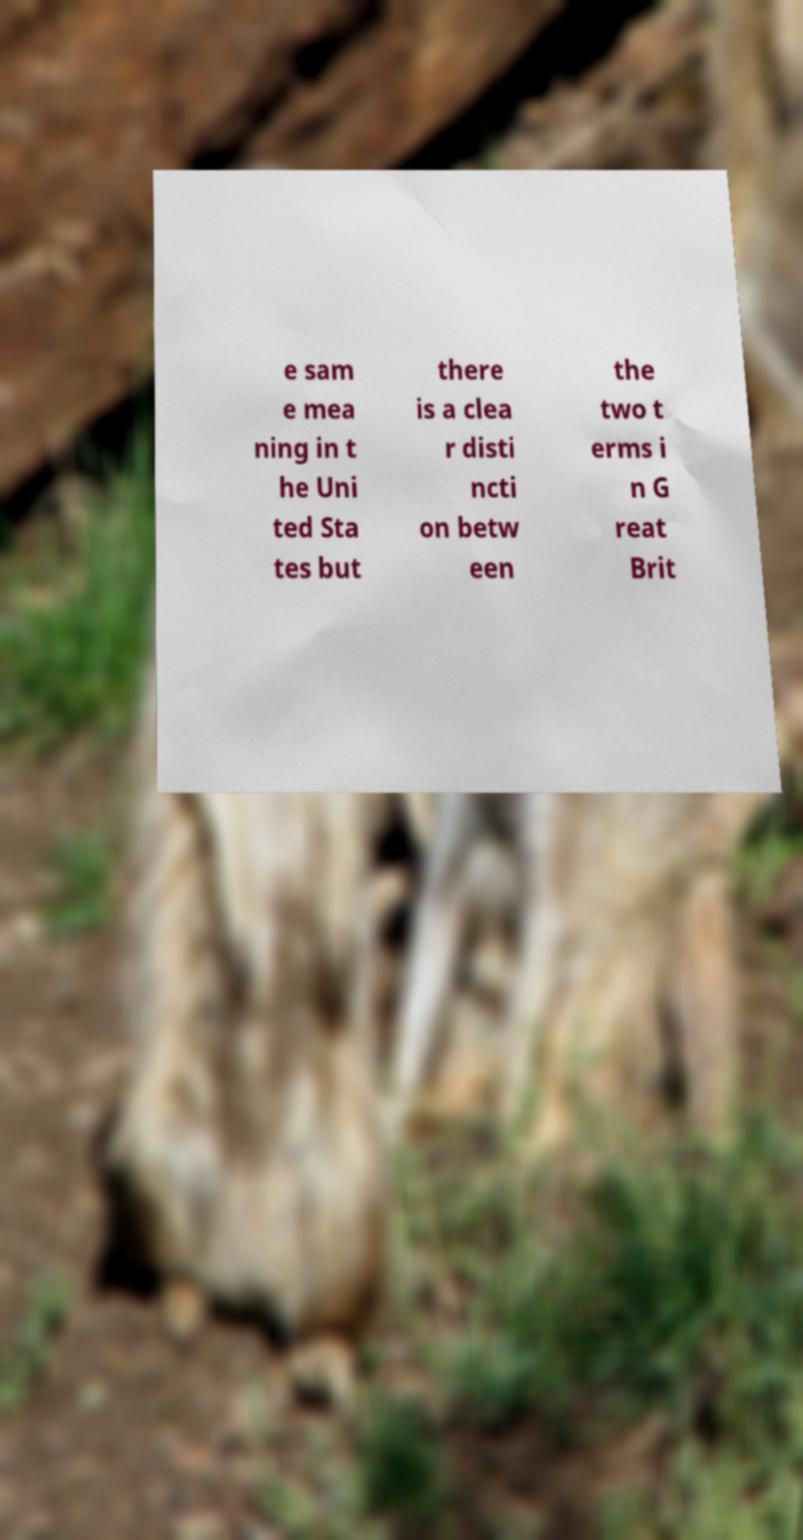Could you assist in decoding the text presented in this image and type it out clearly? e sam e mea ning in t he Uni ted Sta tes but there is a clea r disti ncti on betw een the two t erms i n G reat Brit 